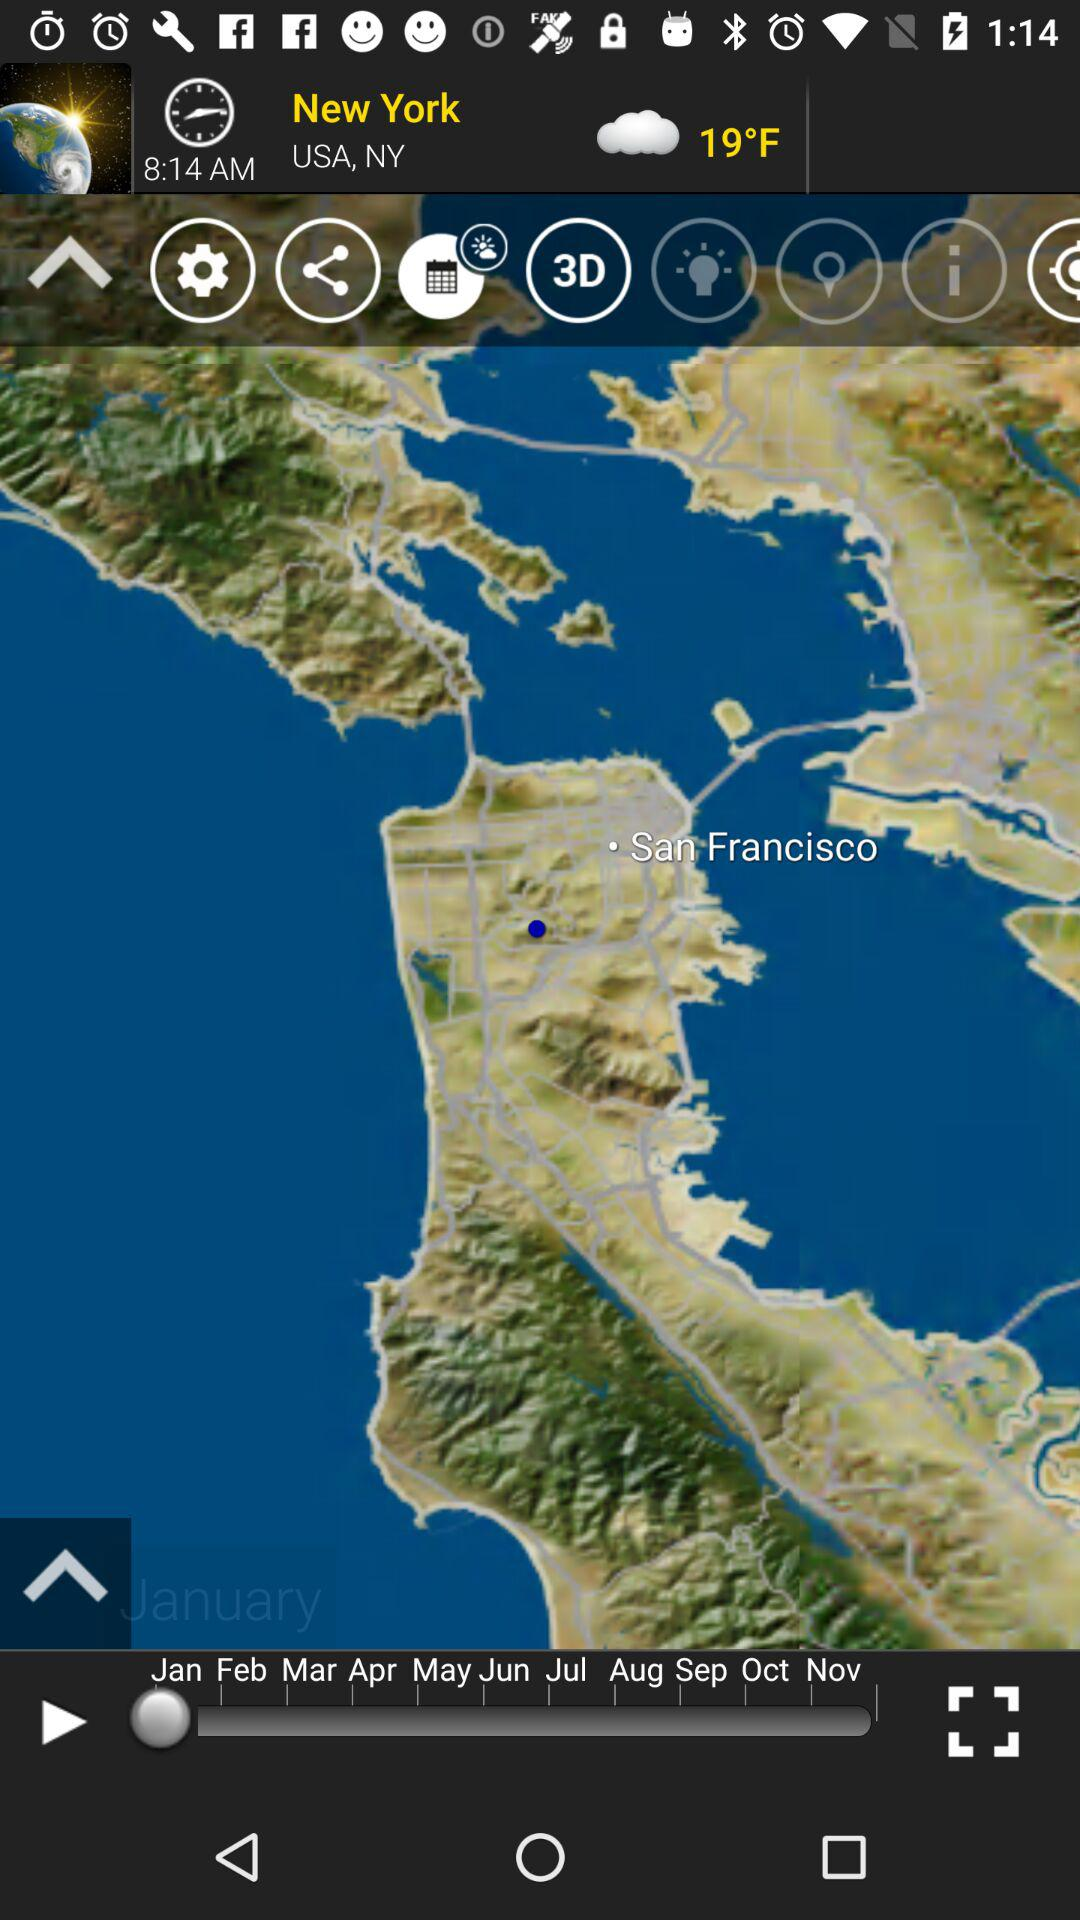What is the temperature? The temperature is 19°F. 